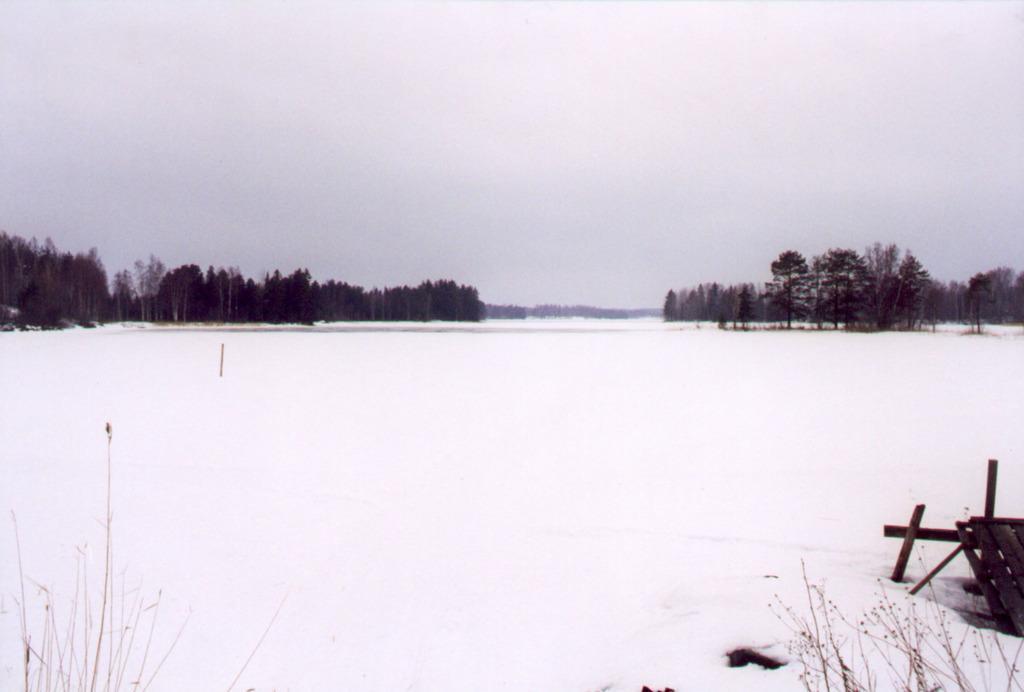Please provide a concise description of this image. In this picture we can see full of snow, around we can see some trees. 